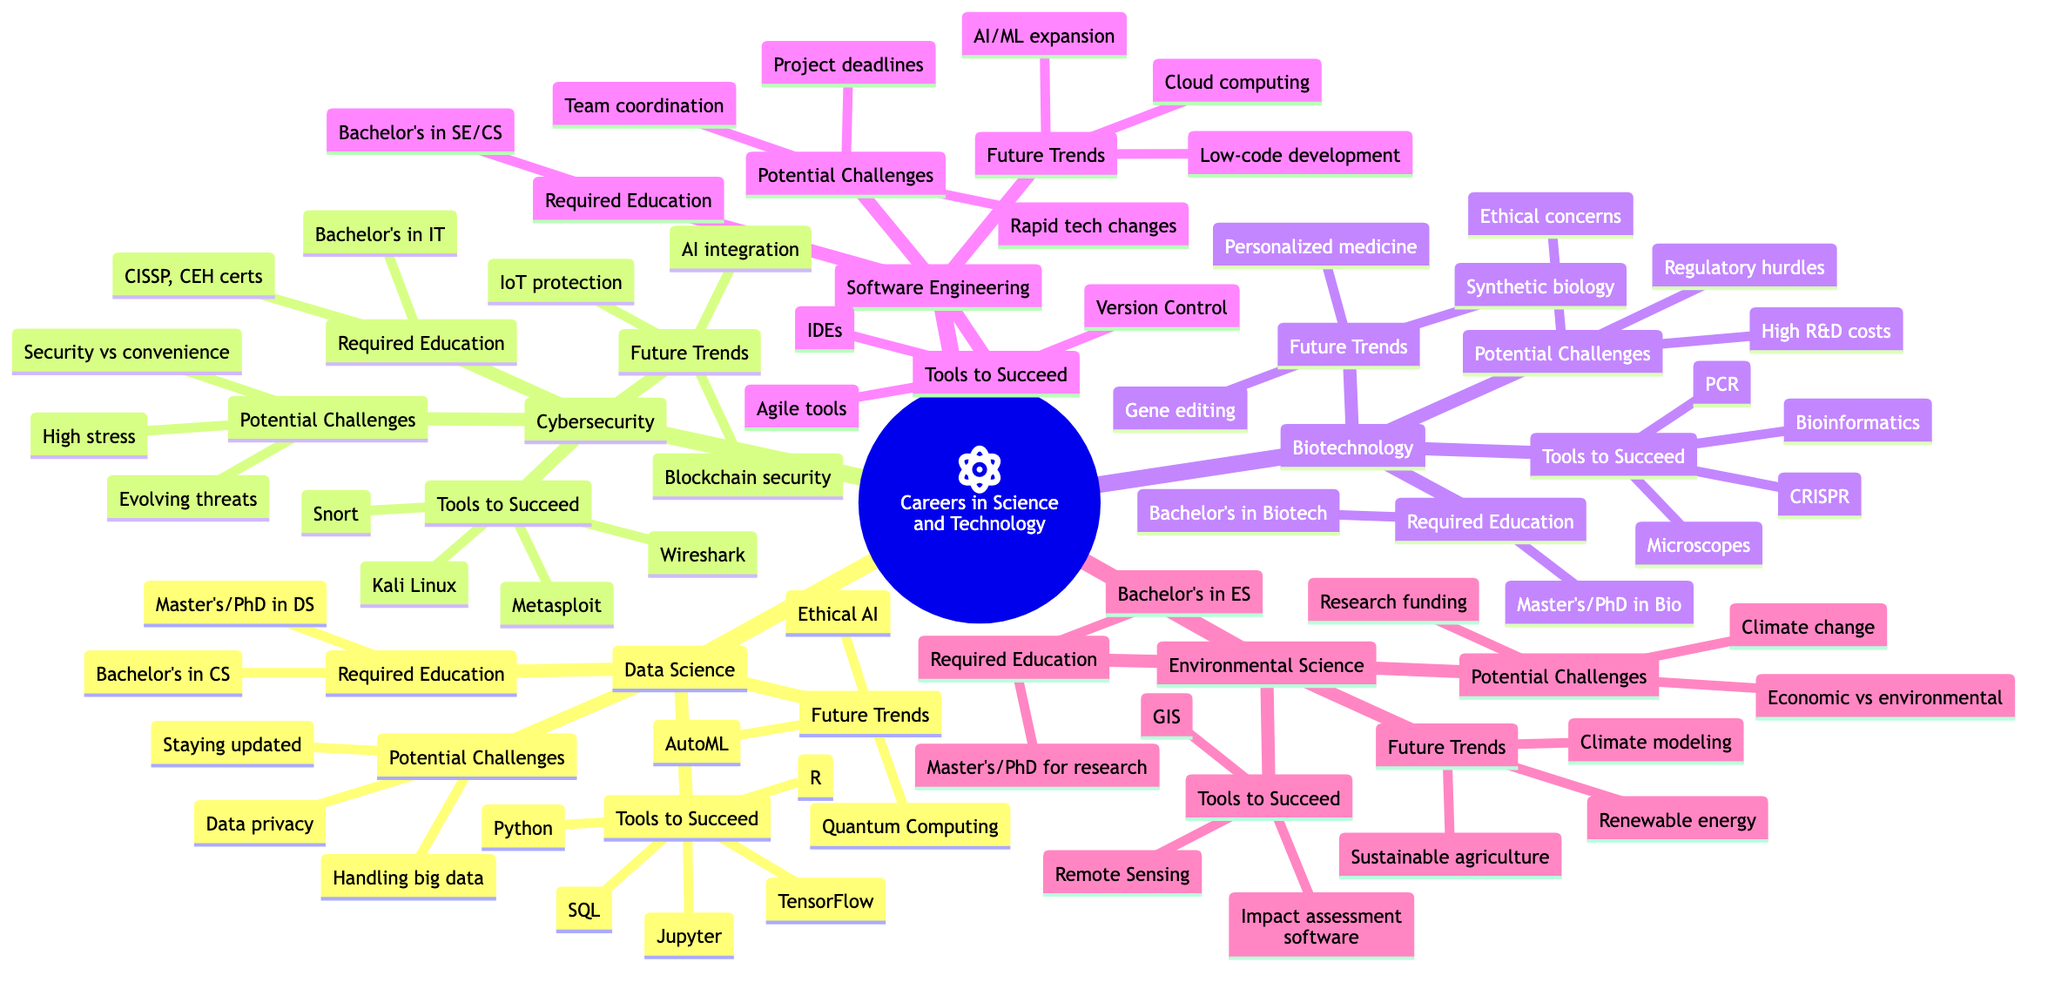What are the required education levels for Data Science? In the diagram, under the "Data Science" branch, the "Required Education" section lists two specific degrees: a Bachelor's Degree in Computer Science and a Master's or Ph.D. in Data Science.
Answer: Bachelor's Degree in Computer Science, Master's or Ph.D. in Data Science How many potential challenges are listed for Cybersecurity? In the Cybersecurity branch, there are three listed potential challenges: evolving nature of cyber threats, balancing security with user convenience, and high stress. Counting these challenges gives a total of three.
Answer: 3 What tools are recommended for success in Biotechnology? Looking under the "Biotechnology" section, the "Tools to Succeed" lists PCR, CRISPR, bioinformatics tools, and microscopes. This directly tells us the tools without needing any interpretation.
Answer: PCR, CRISPR, bioinformatics tools, microscopes What is one potential challenge that Environmental Science professionals may face? The diagram under the "Environmental Science" section lists multiple challenges. Any of these challenges, such as funding for field research, balancing economic and environmental interests, or global climate change would suffice as an answer. We just need one, so we can choose the first one directly from the list.
Answer: Funding for field research What future trend is associated with Software Engineering? Under the "Software Engineering" branch, the "Future Trends" section lists multiple future trends including increased use of cloud computing, rise of low-code development, and expansion of AI and machine learning applications. Picking any one of these trends would answer the question satisfactorily.
Answer: Increased use of cloud computing 